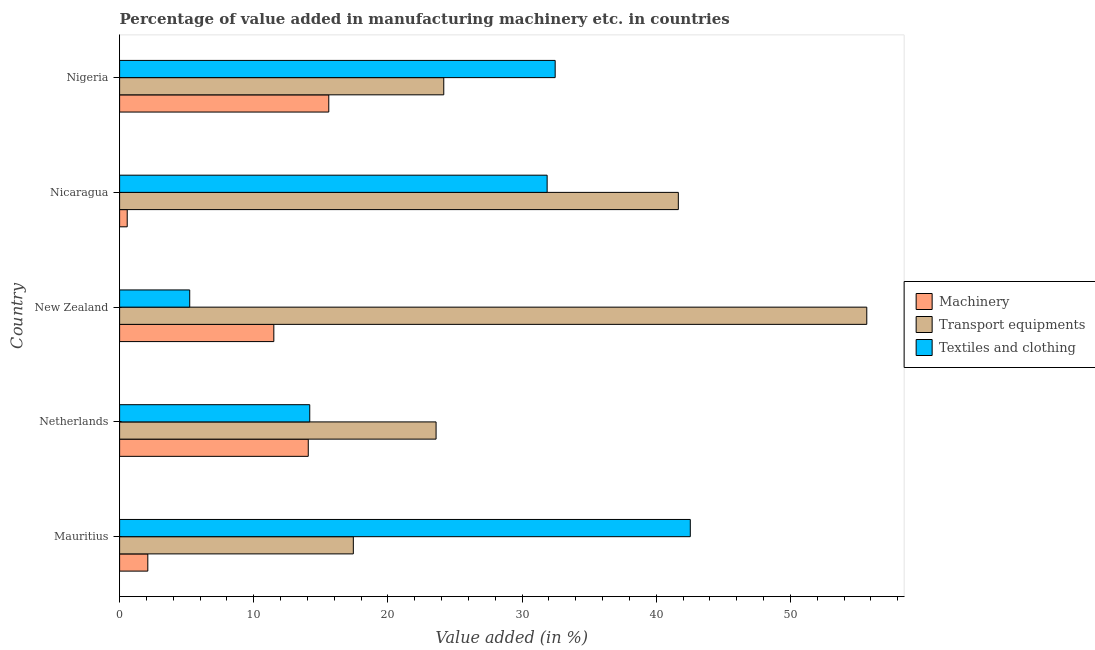How many different coloured bars are there?
Offer a very short reply. 3. How many groups of bars are there?
Give a very brief answer. 5. Are the number of bars on each tick of the Y-axis equal?
Offer a terse response. Yes. How many bars are there on the 1st tick from the top?
Keep it short and to the point. 3. What is the label of the 4th group of bars from the top?
Provide a short and direct response. Netherlands. In how many cases, is the number of bars for a given country not equal to the number of legend labels?
Give a very brief answer. 0. What is the value added in manufacturing machinery in New Zealand?
Provide a short and direct response. 11.49. Across all countries, what is the maximum value added in manufacturing transport equipments?
Give a very brief answer. 55.69. Across all countries, what is the minimum value added in manufacturing textile and clothing?
Keep it short and to the point. 5.23. In which country was the value added in manufacturing textile and clothing maximum?
Offer a very short reply. Mauritius. In which country was the value added in manufacturing textile and clothing minimum?
Give a very brief answer. New Zealand. What is the total value added in manufacturing textile and clothing in the graph?
Your response must be concise. 126.27. What is the difference between the value added in manufacturing textile and clothing in Mauritius and that in Nicaragua?
Make the answer very short. 10.67. What is the difference between the value added in manufacturing machinery in Mauritius and the value added in manufacturing transport equipments in Nicaragua?
Your answer should be very brief. -39.54. What is the average value added in manufacturing textile and clothing per country?
Keep it short and to the point. 25.25. What is the difference between the value added in manufacturing machinery and value added in manufacturing textile and clothing in Netherlands?
Give a very brief answer. -0.11. In how many countries, is the value added in manufacturing textile and clothing greater than 34 %?
Your answer should be very brief. 1. What is the ratio of the value added in manufacturing transport equipments in Mauritius to that in Nigeria?
Give a very brief answer. 0.72. Is the value added in manufacturing textile and clothing in Mauritius less than that in Nicaragua?
Offer a terse response. No. Is the difference between the value added in manufacturing machinery in Netherlands and New Zealand greater than the difference between the value added in manufacturing textile and clothing in Netherlands and New Zealand?
Offer a very short reply. No. What is the difference between the highest and the second highest value added in manufacturing machinery?
Offer a very short reply. 1.53. What is the difference between the highest and the lowest value added in manufacturing transport equipments?
Provide a short and direct response. 38.27. In how many countries, is the value added in manufacturing textile and clothing greater than the average value added in manufacturing textile and clothing taken over all countries?
Provide a short and direct response. 3. Is the sum of the value added in manufacturing transport equipments in Mauritius and Nigeria greater than the maximum value added in manufacturing textile and clothing across all countries?
Your answer should be very brief. No. What does the 3rd bar from the top in New Zealand represents?
Provide a succinct answer. Machinery. What does the 3rd bar from the bottom in Mauritius represents?
Make the answer very short. Textiles and clothing. Is it the case that in every country, the sum of the value added in manufacturing machinery and value added in manufacturing transport equipments is greater than the value added in manufacturing textile and clothing?
Your answer should be compact. No. Are all the bars in the graph horizontal?
Offer a very short reply. Yes. What is the difference between two consecutive major ticks on the X-axis?
Ensure brevity in your answer.  10. Does the graph contain any zero values?
Ensure brevity in your answer.  No. How many legend labels are there?
Your answer should be compact. 3. How are the legend labels stacked?
Your answer should be compact. Vertical. What is the title of the graph?
Offer a terse response. Percentage of value added in manufacturing machinery etc. in countries. Does "Agricultural Nitrous Oxide" appear as one of the legend labels in the graph?
Provide a succinct answer. No. What is the label or title of the X-axis?
Ensure brevity in your answer.  Value added (in %). What is the label or title of the Y-axis?
Keep it short and to the point. Country. What is the Value added (in %) of Machinery in Mauritius?
Your response must be concise. 2.1. What is the Value added (in %) of Transport equipments in Mauritius?
Ensure brevity in your answer.  17.42. What is the Value added (in %) of Textiles and clothing in Mauritius?
Provide a short and direct response. 42.54. What is the Value added (in %) in Machinery in Netherlands?
Offer a terse response. 14.06. What is the Value added (in %) of Transport equipments in Netherlands?
Keep it short and to the point. 23.59. What is the Value added (in %) of Textiles and clothing in Netherlands?
Give a very brief answer. 14.17. What is the Value added (in %) of Machinery in New Zealand?
Offer a terse response. 11.49. What is the Value added (in %) of Transport equipments in New Zealand?
Your response must be concise. 55.69. What is the Value added (in %) in Textiles and clothing in New Zealand?
Keep it short and to the point. 5.23. What is the Value added (in %) in Machinery in Nicaragua?
Offer a terse response. 0.57. What is the Value added (in %) of Transport equipments in Nicaragua?
Provide a succinct answer. 41.64. What is the Value added (in %) of Textiles and clothing in Nicaragua?
Your response must be concise. 31.87. What is the Value added (in %) in Machinery in Nigeria?
Offer a terse response. 15.59. What is the Value added (in %) in Transport equipments in Nigeria?
Provide a short and direct response. 24.16. What is the Value added (in %) in Textiles and clothing in Nigeria?
Your response must be concise. 32.46. Across all countries, what is the maximum Value added (in %) of Machinery?
Your response must be concise. 15.59. Across all countries, what is the maximum Value added (in %) of Transport equipments?
Provide a short and direct response. 55.69. Across all countries, what is the maximum Value added (in %) of Textiles and clothing?
Give a very brief answer. 42.54. Across all countries, what is the minimum Value added (in %) in Machinery?
Ensure brevity in your answer.  0.57. Across all countries, what is the minimum Value added (in %) in Transport equipments?
Your answer should be very brief. 17.42. Across all countries, what is the minimum Value added (in %) in Textiles and clothing?
Offer a terse response. 5.23. What is the total Value added (in %) in Machinery in the graph?
Keep it short and to the point. 43.82. What is the total Value added (in %) in Transport equipments in the graph?
Offer a terse response. 162.5. What is the total Value added (in %) in Textiles and clothing in the graph?
Provide a short and direct response. 126.27. What is the difference between the Value added (in %) of Machinery in Mauritius and that in Netherlands?
Provide a succinct answer. -11.96. What is the difference between the Value added (in %) of Transport equipments in Mauritius and that in Netherlands?
Your answer should be very brief. -6.17. What is the difference between the Value added (in %) of Textiles and clothing in Mauritius and that in Netherlands?
Provide a short and direct response. 28.36. What is the difference between the Value added (in %) in Machinery in Mauritius and that in New Zealand?
Your answer should be very brief. -9.39. What is the difference between the Value added (in %) of Transport equipments in Mauritius and that in New Zealand?
Provide a succinct answer. -38.27. What is the difference between the Value added (in %) in Textiles and clothing in Mauritius and that in New Zealand?
Give a very brief answer. 37.31. What is the difference between the Value added (in %) of Machinery in Mauritius and that in Nicaragua?
Your answer should be compact. 1.53. What is the difference between the Value added (in %) of Transport equipments in Mauritius and that in Nicaragua?
Give a very brief answer. -24.22. What is the difference between the Value added (in %) of Textiles and clothing in Mauritius and that in Nicaragua?
Your response must be concise. 10.67. What is the difference between the Value added (in %) in Machinery in Mauritius and that in Nigeria?
Offer a very short reply. -13.49. What is the difference between the Value added (in %) of Transport equipments in Mauritius and that in Nigeria?
Your answer should be compact. -6.74. What is the difference between the Value added (in %) in Textiles and clothing in Mauritius and that in Nigeria?
Make the answer very short. 10.07. What is the difference between the Value added (in %) in Machinery in Netherlands and that in New Zealand?
Give a very brief answer. 2.57. What is the difference between the Value added (in %) of Transport equipments in Netherlands and that in New Zealand?
Your answer should be compact. -32.1. What is the difference between the Value added (in %) in Textiles and clothing in Netherlands and that in New Zealand?
Offer a terse response. 8.95. What is the difference between the Value added (in %) of Machinery in Netherlands and that in Nicaragua?
Keep it short and to the point. 13.49. What is the difference between the Value added (in %) in Transport equipments in Netherlands and that in Nicaragua?
Give a very brief answer. -18.06. What is the difference between the Value added (in %) in Textiles and clothing in Netherlands and that in Nicaragua?
Ensure brevity in your answer.  -17.69. What is the difference between the Value added (in %) in Machinery in Netherlands and that in Nigeria?
Provide a succinct answer. -1.53. What is the difference between the Value added (in %) of Transport equipments in Netherlands and that in Nigeria?
Keep it short and to the point. -0.57. What is the difference between the Value added (in %) of Textiles and clothing in Netherlands and that in Nigeria?
Provide a short and direct response. -18.29. What is the difference between the Value added (in %) of Machinery in New Zealand and that in Nicaragua?
Your response must be concise. 10.93. What is the difference between the Value added (in %) of Transport equipments in New Zealand and that in Nicaragua?
Provide a succinct answer. 14.05. What is the difference between the Value added (in %) of Textiles and clothing in New Zealand and that in Nicaragua?
Your answer should be very brief. -26.64. What is the difference between the Value added (in %) of Machinery in New Zealand and that in Nigeria?
Provide a succinct answer. -4.1. What is the difference between the Value added (in %) in Transport equipments in New Zealand and that in Nigeria?
Provide a short and direct response. 31.53. What is the difference between the Value added (in %) of Textiles and clothing in New Zealand and that in Nigeria?
Offer a very short reply. -27.24. What is the difference between the Value added (in %) in Machinery in Nicaragua and that in Nigeria?
Offer a very short reply. -15.02. What is the difference between the Value added (in %) in Transport equipments in Nicaragua and that in Nigeria?
Your answer should be very brief. 17.48. What is the difference between the Value added (in %) in Textiles and clothing in Nicaragua and that in Nigeria?
Provide a short and direct response. -0.6. What is the difference between the Value added (in %) of Machinery in Mauritius and the Value added (in %) of Transport equipments in Netherlands?
Offer a very short reply. -21.49. What is the difference between the Value added (in %) of Machinery in Mauritius and the Value added (in %) of Textiles and clothing in Netherlands?
Ensure brevity in your answer.  -12.07. What is the difference between the Value added (in %) in Transport equipments in Mauritius and the Value added (in %) in Textiles and clothing in Netherlands?
Give a very brief answer. 3.25. What is the difference between the Value added (in %) in Machinery in Mauritius and the Value added (in %) in Transport equipments in New Zealand?
Your answer should be very brief. -53.59. What is the difference between the Value added (in %) in Machinery in Mauritius and the Value added (in %) in Textiles and clothing in New Zealand?
Provide a short and direct response. -3.12. What is the difference between the Value added (in %) of Transport equipments in Mauritius and the Value added (in %) of Textiles and clothing in New Zealand?
Keep it short and to the point. 12.19. What is the difference between the Value added (in %) in Machinery in Mauritius and the Value added (in %) in Transport equipments in Nicaragua?
Provide a succinct answer. -39.54. What is the difference between the Value added (in %) in Machinery in Mauritius and the Value added (in %) in Textiles and clothing in Nicaragua?
Offer a terse response. -29.76. What is the difference between the Value added (in %) in Transport equipments in Mauritius and the Value added (in %) in Textiles and clothing in Nicaragua?
Your answer should be compact. -14.45. What is the difference between the Value added (in %) in Machinery in Mauritius and the Value added (in %) in Transport equipments in Nigeria?
Ensure brevity in your answer.  -22.06. What is the difference between the Value added (in %) of Machinery in Mauritius and the Value added (in %) of Textiles and clothing in Nigeria?
Ensure brevity in your answer.  -30.36. What is the difference between the Value added (in %) of Transport equipments in Mauritius and the Value added (in %) of Textiles and clothing in Nigeria?
Ensure brevity in your answer.  -15.04. What is the difference between the Value added (in %) in Machinery in Netherlands and the Value added (in %) in Transport equipments in New Zealand?
Keep it short and to the point. -41.63. What is the difference between the Value added (in %) of Machinery in Netherlands and the Value added (in %) of Textiles and clothing in New Zealand?
Provide a short and direct response. 8.84. What is the difference between the Value added (in %) of Transport equipments in Netherlands and the Value added (in %) of Textiles and clothing in New Zealand?
Give a very brief answer. 18.36. What is the difference between the Value added (in %) in Machinery in Netherlands and the Value added (in %) in Transport equipments in Nicaragua?
Keep it short and to the point. -27.58. What is the difference between the Value added (in %) in Machinery in Netherlands and the Value added (in %) in Textiles and clothing in Nicaragua?
Your response must be concise. -17.8. What is the difference between the Value added (in %) of Transport equipments in Netherlands and the Value added (in %) of Textiles and clothing in Nicaragua?
Provide a succinct answer. -8.28. What is the difference between the Value added (in %) of Machinery in Netherlands and the Value added (in %) of Transport equipments in Nigeria?
Your answer should be very brief. -10.1. What is the difference between the Value added (in %) in Machinery in Netherlands and the Value added (in %) in Textiles and clothing in Nigeria?
Give a very brief answer. -18.4. What is the difference between the Value added (in %) in Transport equipments in Netherlands and the Value added (in %) in Textiles and clothing in Nigeria?
Give a very brief answer. -8.88. What is the difference between the Value added (in %) in Machinery in New Zealand and the Value added (in %) in Transport equipments in Nicaragua?
Your answer should be compact. -30.15. What is the difference between the Value added (in %) in Machinery in New Zealand and the Value added (in %) in Textiles and clothing in Nicaragua?
Offer a terse response. -20.37. What is the difference between the Value added (in %) in Transport equipments in New Zealand and the Value added (in %) in Textiles and clothing in Nicaragua?
Your answer should be compact. 23.82. What is the difference between the Value added (in %) of Machinery in New Zealand and the Value added (in %) of Transport equipments in Nigeria?
Provide a succinct answer. -12.67. What is the difference between the Value added (in %) in Machinery in New Zealand and the Value added (in %) in Textiles and clothing in Nigeria?
Make the answer very short. -20.97. What is the difference between the Value added (in %) of Transport equipments in New Zealand and the Value added (in %) of Textiles and clothing in Nigeria?
Make the answer very short. 23.23. What is the difference between the Value added (in %) of Machinery in Nicaragua and the Value added (in %) of Transport equipments in Nigeria?
Make the answer very short. -23.59. What is the difference between the Value added (in %) in Machinery in Nicaragua and the Value added (in %) in Textiles and clothing in Nigeria?
Provide a succinct answer. -31.9. What is the difference between the Value added (in %) of Transport equipments in Nicaragua and the Value added (in %) of Textiles and clothing in Nigeria?
Give a very brief answer. 9.18. What is the average Value added (in %) in Machinery per country?
Offer a very short reply. 8.76. What is the average Value added (in %) in Transport equipments per country?
Your answer should be very brief. 32.5. What is the average Value added (in %) of Textiles and clothing per country?
Offer a terse response. 25.25. What is the difference between the Value added (in %) in Machinery and Value added (in %) in Transport equipments in Mauritius?
Offer a very short reply. -15.32. What is the difference between the Value added (in %) in Machinery and Value added (in %) in Textiles and clothing in Mauritius?
Your response must be concise. -40.43. What is the difference between the Value added (in %) of Transport equipments and Value added (in %) of Textiles and clothing in Mauritius?
Provide a succinct answer. -25.12. What is the difference between the Value added (in %) of Machinery and Value added (in %) of Transport equipments in Netherlands?
Keep it short and to the point. -9.53. What is the difference between the Value added (in %) of Machinery and Value added (in %) of Textiles and clothing in Netherlands?
Make the answer very short. -0.11. What is the difference between the Value added (in %) in Transport equipments and Value added (in %) in Textiles and clothing in Netherlands?
Your answer should be very brief. 9.42. What is the difference between the Value added (in %) of Machinery and Value added (in %) of Transport equipments in New Zealand?
Make the answer very short. -44.2. What is the difference between the Value added (in %) in Machinery and Value added (in %) in Textiles and clothing in New Zealand?
Keep it short and to the point. 6.27. What is the difference between the Value added (in %) in Transport equipments and Value added (in %) in Textiles and clothing in New Zealand?
Offer a terse response. 50.46. What is the difference between the Value added (in %) in Machinery and Value added (in %) in Transport equipments in Nicaragua?
Ensure brevity in your answer.  -41.08. What is the difference between the Value added (in %) in Machinery and Value added (in %) in Textiles and clothing in Nicaragua?
Give a very brief answer. -31.3. What is the difference between the Value added (in %) in Transport equipments and Value added (in %) in Textiles and clothing in Nicaragua?
Give a very brief answer. 9.78. What is the difference between the Value added (in %) of Machinery and Value added (in %) of Transport equipments in Nigeria?
Provide a succinct answer. -8.57. What is the difference between the Value added (in %) of Machinery and Value added (in %) of Textiles and clothing in Nigeria?
Provide a short and direct response. -16.87. What is the difference between the Value added (in %) of Transport equipments and Value added (in %) of Textiles and clothing in Nigeria?
Ensure brevity in your answer.  -8.3. What is the ratio of the Value added (in %) in Machinery in Mauritius to that in Netherlands?
Your response must be concise. 0.15. What is the ratio of the Value added (in %) of Transport equipments in Mauritius to that in Netherlands?
Make the answer very short. 0.74. What is the ratio of the Value added (in %) of Textiles and clothing in Mauritius to that in Netherlands?
Ensure brevity in your answer.  3. What is the ratio of the Value added (in %) in Machinery in Mauritius to that in New Zealand?
Your answer should be compact. 0.18. What is the ratio of the Value added (in %) of Transport equipments in Mauritius to that in New Zealand?
Offer a terse response. 0.31. What is the ratio of the Value added (in %) of Textiles and clothing in Mauritius to that in New Zealand?
Offer a terse response. 8.14. What is the ratio of the Value added (in %) of Machinery in Mauritius to that in Nicaragua?
Provide a succinct answer. 3.7. What is the ratio of the Value added (in %) in Transport equipments in Mauritius to that in Nicaragua?
Provide a short and direct response. 0.42. What is the ratio of the Value added (in %) of Textiles and clothing in Mauritius to that in Nicaragua?
Give a very brief answer. 1.33. What is the ratio of the Value added (in %) in Machinery in Mauritius to that in Nigeria?
Make the answer very short. 0.13. What is the ratio of the Value added (in %) of Transport equipments in Mauritius to that in Nigeria?
Keep it short and to the point. 0.72. What is the ratio of the Value added (in %) in Textiles and clothing in Mauritius to that in Nigeria?
Provide a short and direct response. 1.31. What is the ratio of the Value added (in %) in Machinery in Netherlands to that in New Zealand?
Give a very brief answer. 1.22. What is the ratio of the Value added (in %) of Transport equipments in Netherlands to that in New Zealand?
Provide a succinct answer. 0.42. What is the ratio of the Value added (in %) in Textiles and clothing in Netherlands to that in New Zealand?
Ensure brevity in your answer.  2.71. What is the ratio of the Value added (in %) of Machinery in Netherlands to that in Nicaragua?
Your answer should be very brief. 24.76. What is the ratio of the Value added (in %) of Transport equipments in Netherlands to that in Nicaragua?
Your answer should be very brief. 0.57. What is the ratio of the Value added (in %) of Textiles and clothing in Netherlands to that in Nicaragua?
Provide a short and direct response. 0.44. What is the ratio of the Value added (in %) of Machinery in Netherlands to that in Nigeria?
Provide a succinct answer. 0.9. What is the ratio of the Value added (in %) in Transport equipments in Netherlands to that in Nigeria?
Give a very brief answer. 0.98. What is the ratio of the Value added (in %) in Textiles and clothing in Netherlands to that in Nigeria?
Your response must be concise. 0.44. What is the ratio of the Value added (in %) in Machinery in New Zealand to that in Nicaragua?
Keep it short and to the point. 20.24. What is the ratio of the Value added (in %) of Transport equipments in New Zealand to that in Nicaragua?
Your answer should be very brief. 1.34. What is the ratio of the Value added (in %) in Textiles and clothing in New Zealand to that in Nicaragua?
Offer a terse response. 0.16. What is the ratio of the Value added (in %) of Machinery in New Zealand to that in Nigeria?
Keep it short and to the point. 0.74. What is the ratio of the Value added (in %) in Transport equipments in New Zealand to that in Nigeria?
Your answer should be compact. 2.3. What is the ratio of the Value added (in %) in Textiles and clothing in New Zealand to that in Nigeria?
Provide a short and direct response. 0.16. What is the ratio of the Value added (in %) of Machinery in Nicaragua to that in Nigeria?
Make the answer very short. 0.04. What is the ratio of the Value added (in %) in Transport equipments in Nicaragua to that in Nigeria?
Provide a short and direct response. 1.72. What is the ratio of the Value added (in %) in Textiles and clothing in Nicaragua to that in Nigeria?
Your answer should be compact. 0.98. What is the difference between the highest and the second highest Value added (in %) of Machinery?
Provide a short and direct response. 1.53. What is the difference between the highest and the second highest Value added (in %) of Transport equipments?
Offer a very short reply. 14.05. What is the difference between the highest and the second highest Value added (in %) in Textiles and clothing?
Keep it short and to the point. 10.07. What is the difference between the highest and the lowest Value added (in %) of Machinery?
Give a very brief answer. 15.02. What is the difference between the highest and the lowest Value added (in %) of Transport equipments?
Ensure brevity in your answer.  38.27. What is the difference between the highest and the lowest Value added (in %) in Textiles and clothing?
Your answer should be compact. 37.31. 